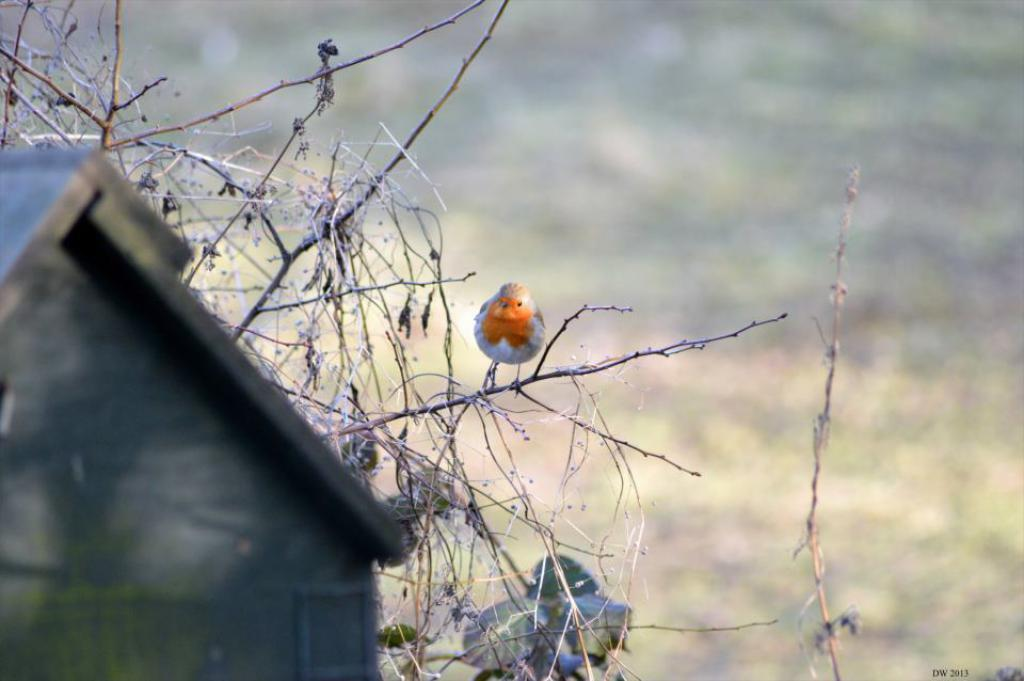What is the main subject of the image? The main subject of the image is a bird standing on a stem. What can be seen in the background of the image? The sky is visible in the image. What is present in the sky? Clouds are present in the sky. What type of steel structure can be seen in the image? There is no steel structure present in the image; it features a bird standing on a stem with clouds in the sky. How many teeth can be seen in the image? There are no teeth visible in the image, as it features a bird standing on a stem with clouds in the sky. 